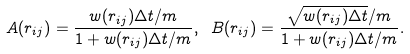<formula> <loc_0><loc_0><loc_500><loc_500>A ( r _ { i j } ) = \frac { w ( r _ { i j } ) \Delta t / m } { 1 + w ( r _ { i j } ) \Delta t / m } , \ B ( r _ { i j } ) = \frac { \sqrt { w ( r _ { i j } ) \Delta t } / m } { 1 + w ( r _ { i j } ) \Delta t / m } .</formula> 